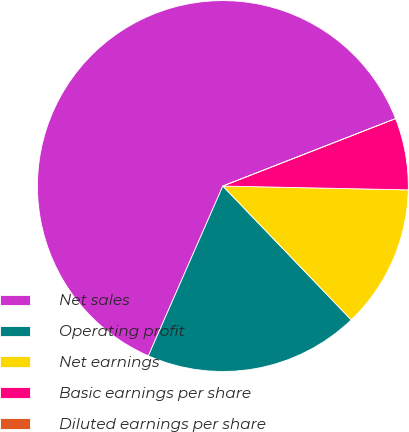<chart> <loc_0><loc_0><loc_500><loc_500><pie_chart><fcel>Net sales<fcel>Operating profit<fcel>Net earnings<fcel>Basic earnings per share<fcel>Diluted earnings per share<nl><fcel>62.49%<fcel>18.75%<fcel>12.5%<fcel>6.25%<fcel>0.0%<nl></chart> 